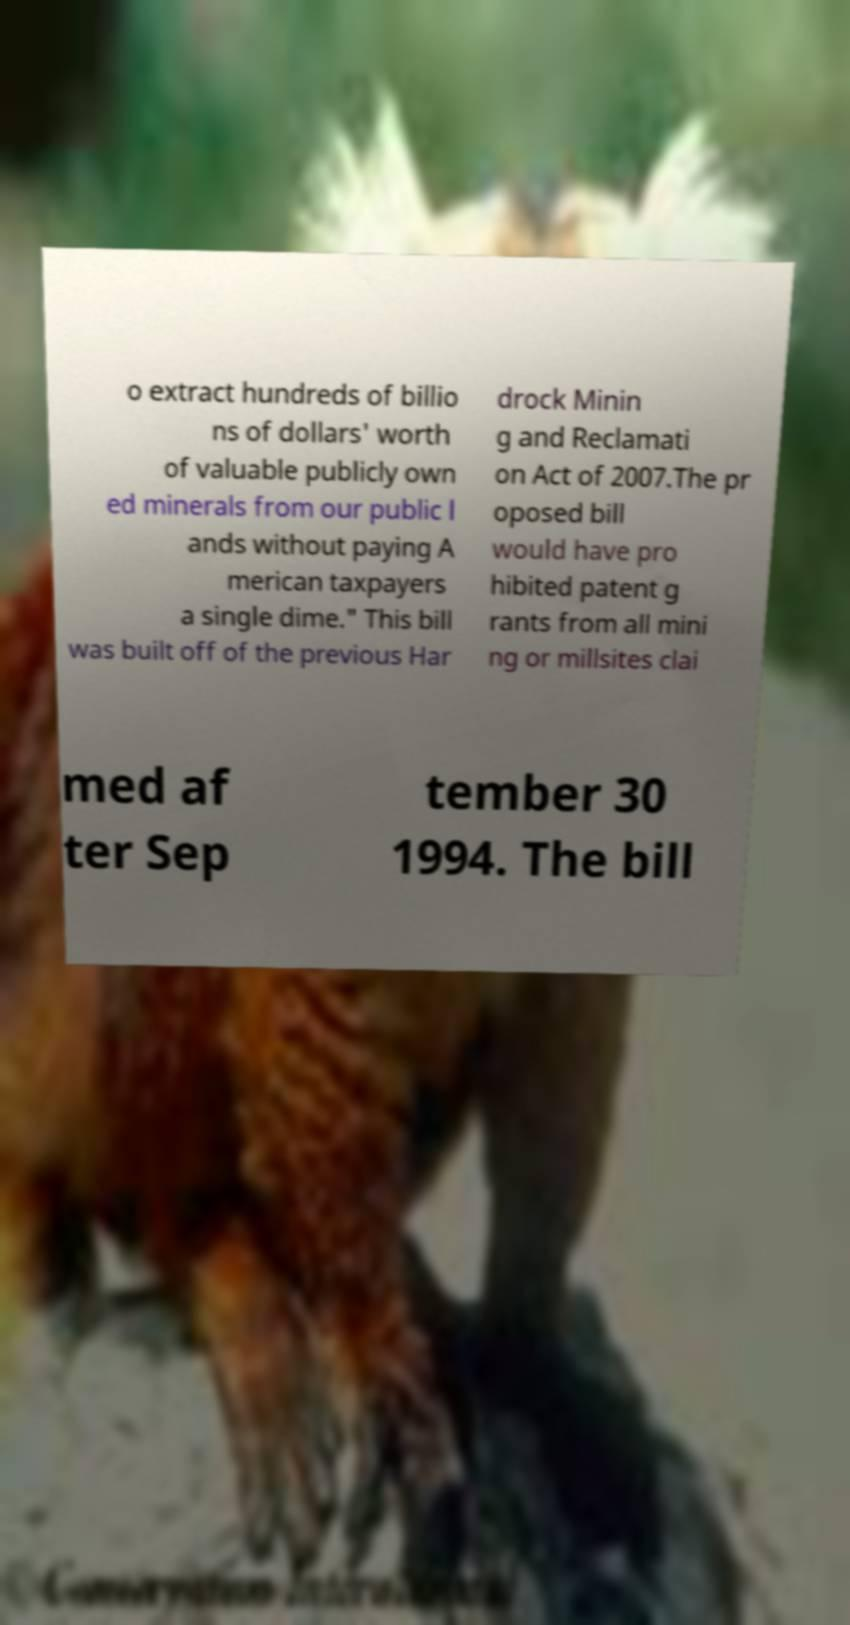Please identify and transcribe the text found in this image. o extract hundreds of billio ns of dollars' worth of valuable publicly own ed minerals from our public l ands without paying A merican taxpayers a single dime." This bill was built off of the previous Har drock Minin g and Reclamati on Act of 2007.The pr oposed bill would have pro hibited patent g rants from all mini ng or millsites clai med af ter Sep tember 30 1994. The bill 